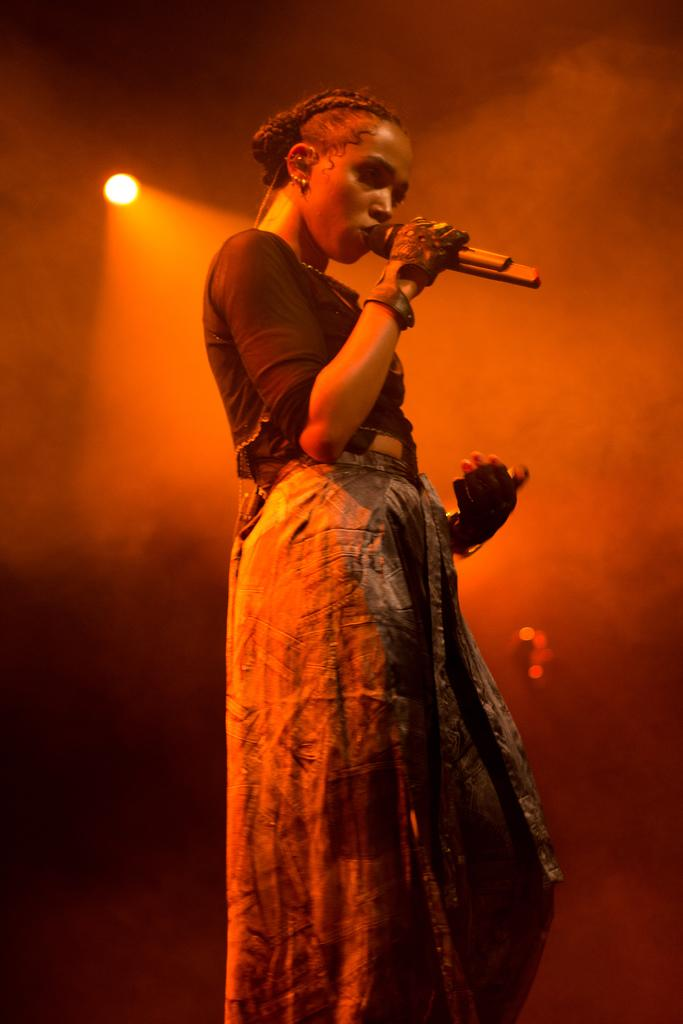Who is the main subject in the image? There is a woman in the image. What is the woman doing in the image? The woman is standing and holding a mic. Can you describe any other elements in the image? There is a light visible in the image. What type of juice is the woman drinking in the image? There is no juice present in the image; the woman is holding a mic. Can you see a kite flying in the background of the image? There is no kite visible in the image; only the woman, her actions, and the light are present. 